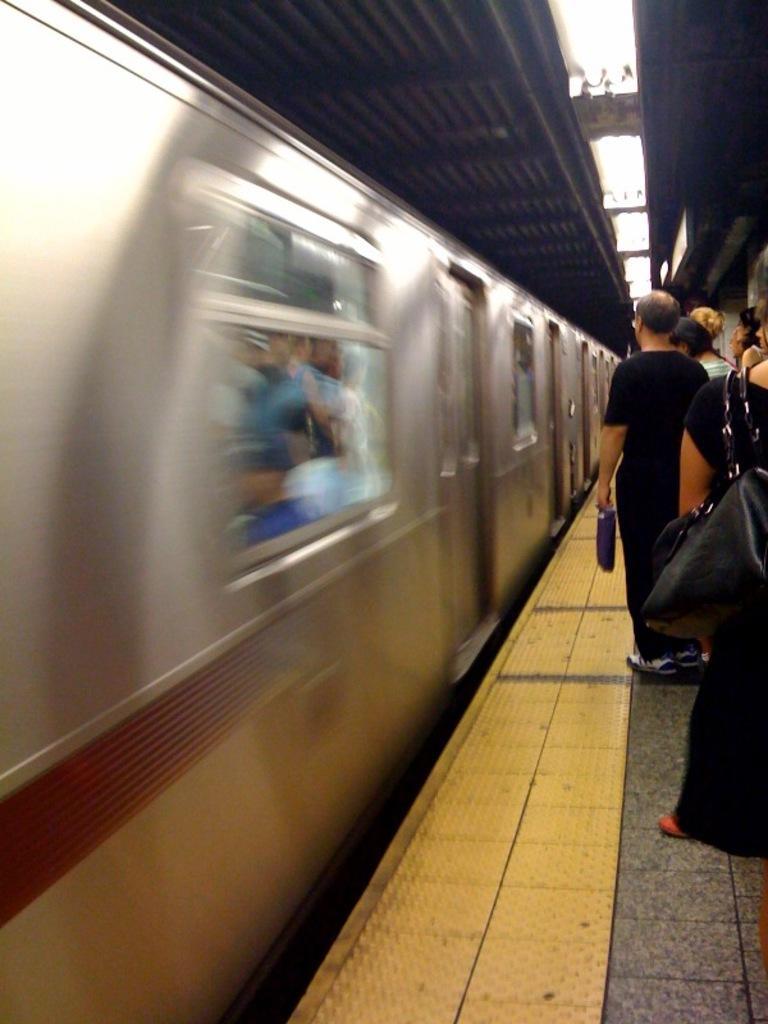Can you describe this image briefly? In this picture we can see a train, inside of this train we can see some people, beside this train we can see a platform and people. 